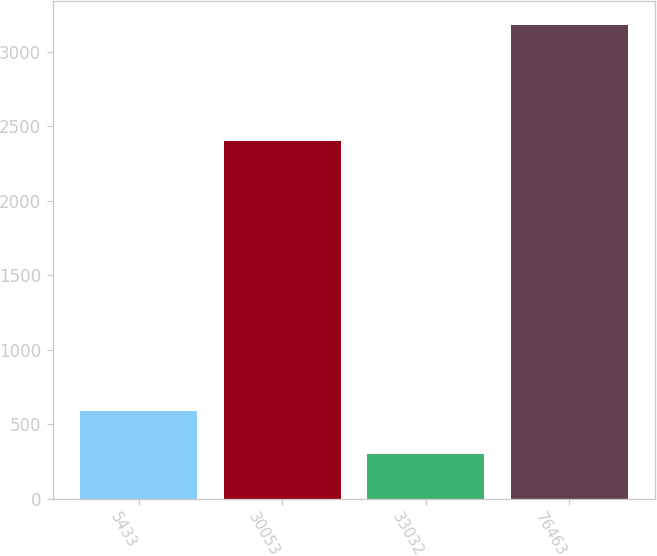<chart> <loc_0><loc_0><loc_500><loc_500><bar_chart><fcel>5433<fcel>30053<fcel>33032<fcel>76463<nl><fcel>587.95<fcel>2396.8<fcel>300.1<fcel>3178.6<nl></chart> 